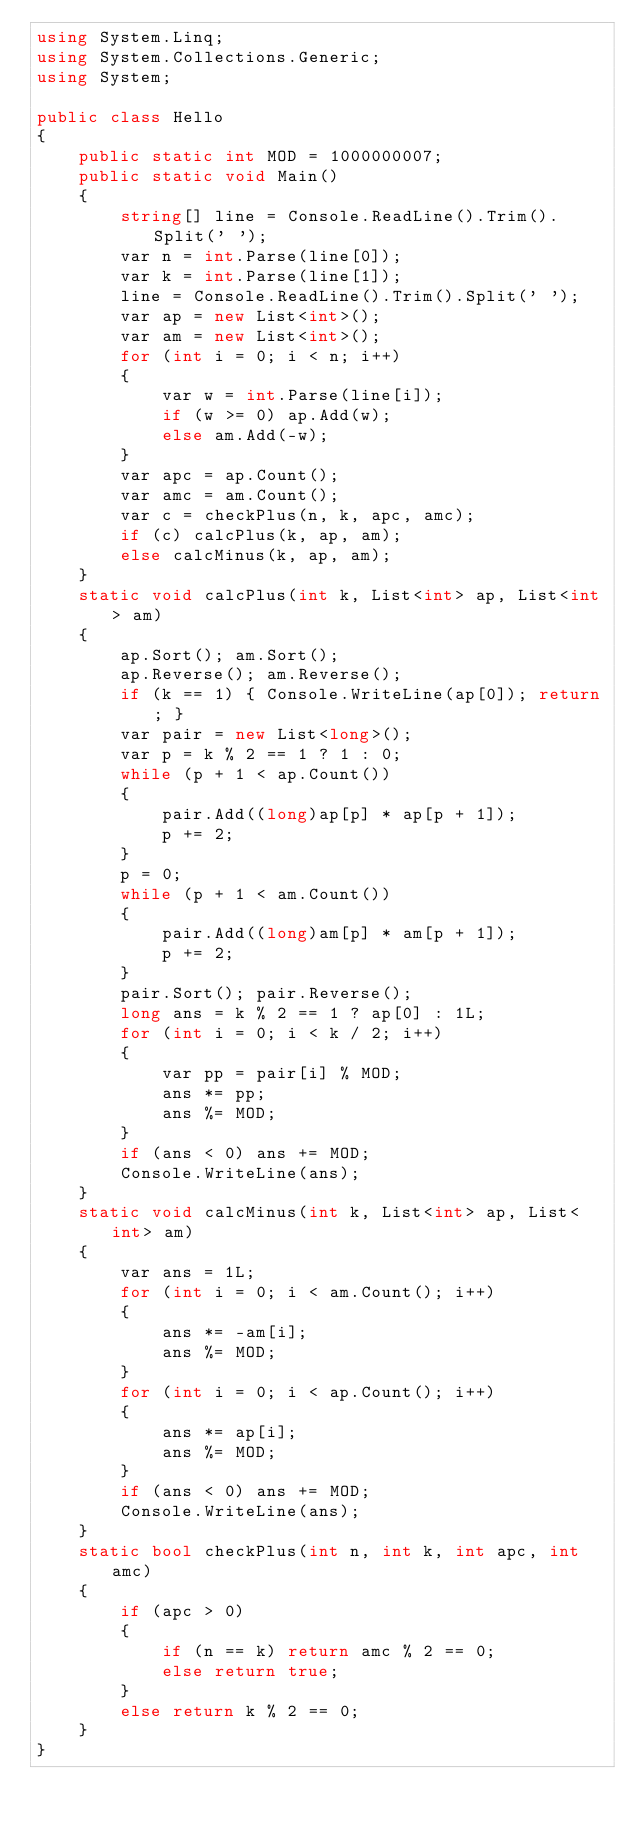<code> <loc_0><loc_0><loc_500><loc_500><_C#_>using System.Linq;
using System.Collections.Generic;
using System;

public class Hello
{
    public static int MOD = 1000000007;
    public static void Main()
    {
        string[] line = Console.ReadLine().Trim().Split(' ');
        var n = int.Parse(line[0]);
        var k = int.Parse(line[1]);
        line = Console.ReadLine().Trim().Split(' ');
        var ap = new List<int>();
        var am = new List<int>();
        for (int i = 0; i < n; i++)
        {
            var w = int.Parse(line[i]);
            if (w >= 0) ap.Add(w);
            else am.Add(-w);
        }
        var apc = ap.Count();
        var amc = am.Count();
        var c = checkPlus(n, k, apc, amc);
        if (c) calcPlus(k, ap, am);
        else calcMinus(k, ap, am);
    }
    static void calcPlus(int k, List<int> ap, List<int> am)
    {
        ap.Sort(); am.Sort();
        ap.Reverse(); am.Reverse();
        if (k == 1) { Console.WriteLine(ap[0]); return; }
        var pair = new List<long>();
        var p = k % 2 == 1 ? 1 : 0;
        while (p + 1 < ap.Count())
        {
            pair.Add((long)ap[p] * ap[p + 1]);
            p += 2;
        }
        p = 0;
        while (p + 1 < am.Count())
        {
            pair.Add((long)am[p] * am[p + 1]);
            p += 2;
        }
        pair.Sort(); pair.Reverse();
        long ans = k % 2 == 1 ? ap[0] : 1L;
        for (int i = 0; i < k / 2; i++)
        {
            var pp = pair[i] % MOD;
            ans *= pp;
            ans %= MOD;
        }
        if (ans < 0) ans += MOD;
        Console.WriteLine(ans);
    }
    static void calcMinus(int k, List<int> ap, List<int> am)
    {
        var ans = 1L;
        for (int i = 0; i < am.Count(); i++)
        {
            ans *= -am[i];
            ans %= MOD;
        }
        for (int i = 0; i < ap.Count(); i++)
        {
            ans *= ap[i];
            ans %= MOD;
        }
        if (ans < 0) ans += MOD;
        Console.WriteLine(ans);
    }
    static bool checkPlus(int n, int k, int apc, int amc)
    {
        if (apc > 0)
        {
            if (n == k) return amc % 2 == 0;
            else return true;
        }
        else return k % 2 == 0;
    }
}
</code> 